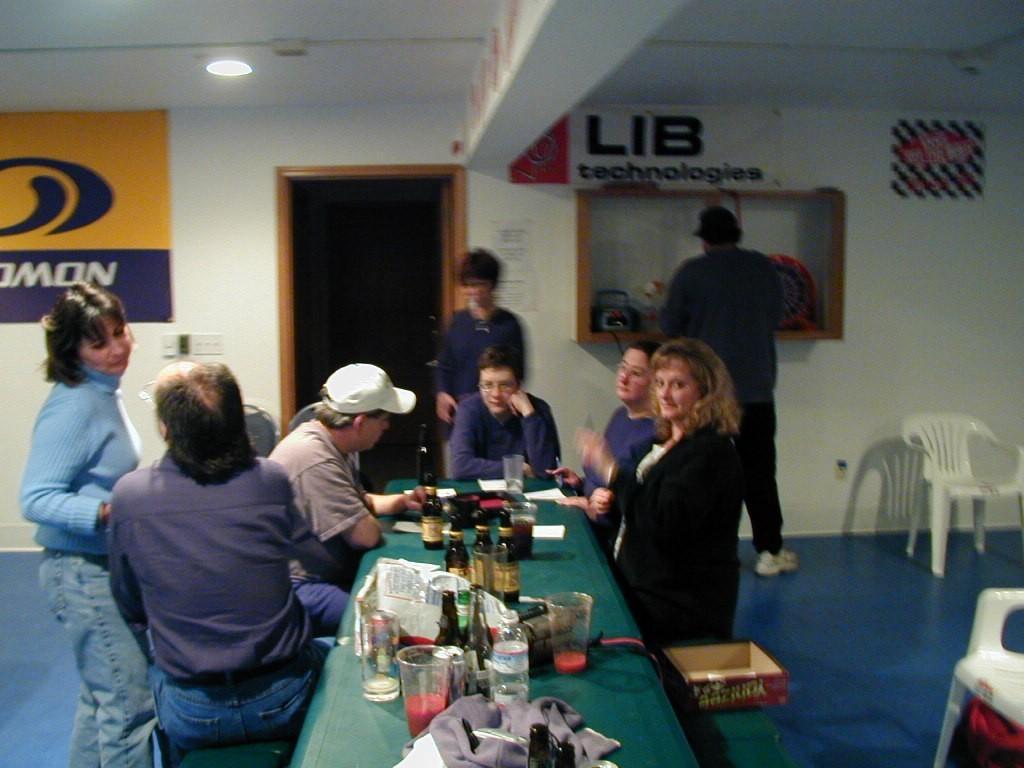Can you describe this image briefly? This is a picture taken in a room, there are a group of people sitting on bench in front of these people there is a table on the table there are glasses, bottles, cloth and a board and some people are standing on the floor. Behind the people there is a door and a wall on the wall there are banners and a switch board. 